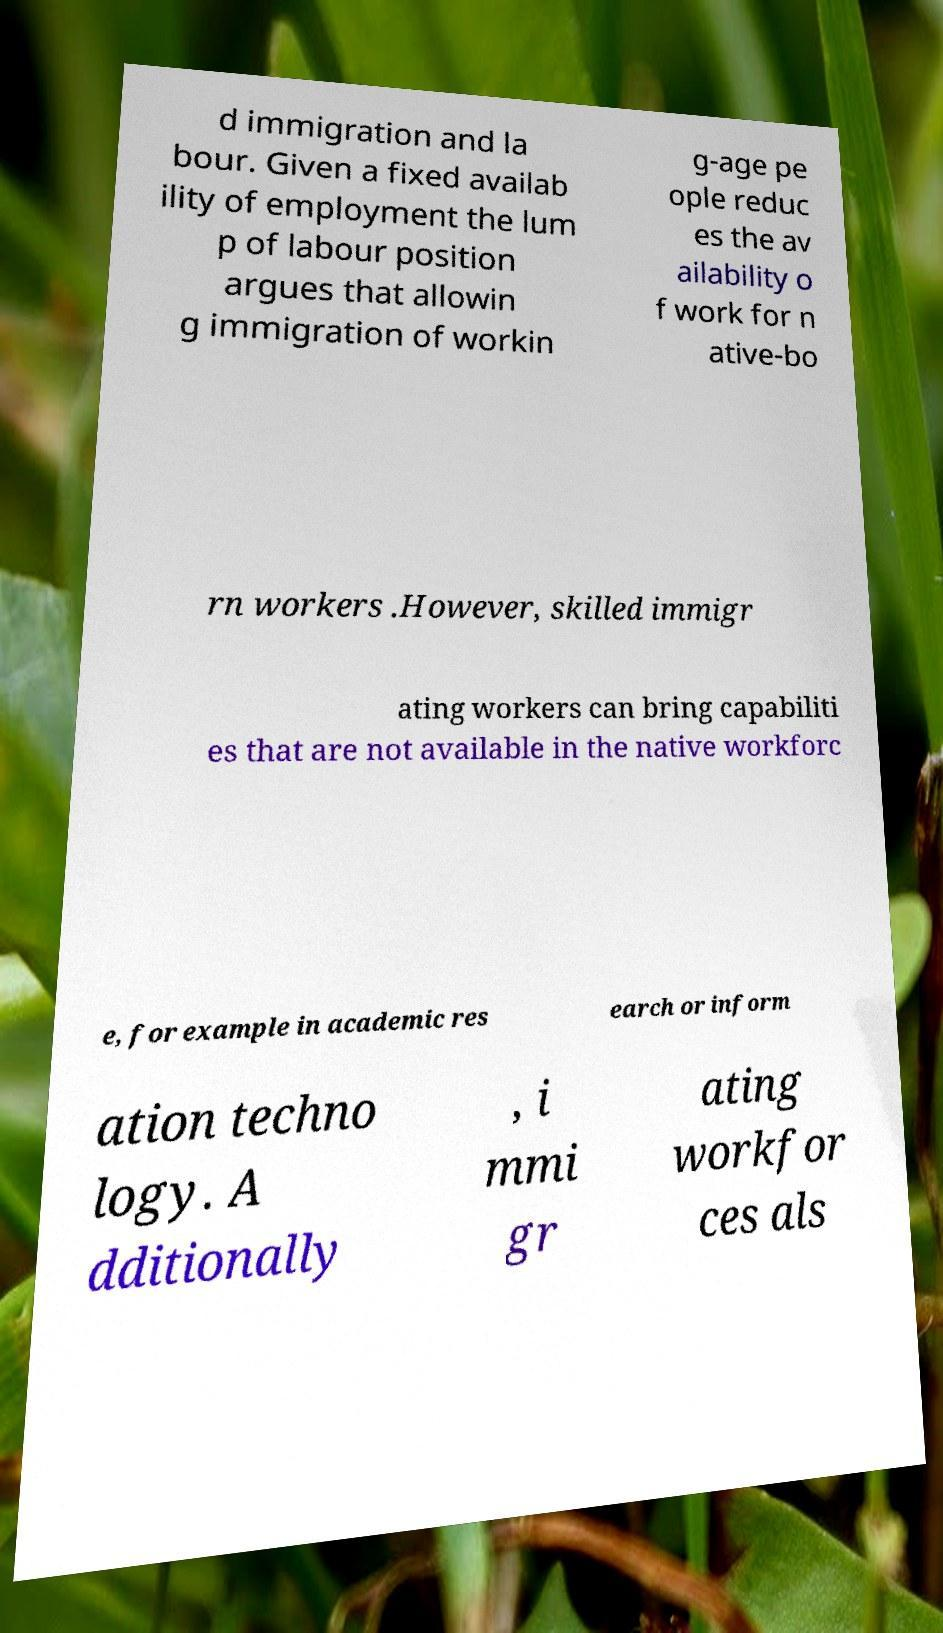Could you assist in decoding the text presented in this image and type it out clearly? d immigration and la bour. Given a fixed availab ility of employment the lum p of labour position argues that allowin g immigration of workin g-age pe ople reduc es the av ailability o f work for n ative-bo rn workers .However, skilled immigr ating workers can bring capabiliti es that are not available in the native workforc e, for example in academic res earch or inform ation techno logy. A dditionally , i mmi gr ating workfor ces als 